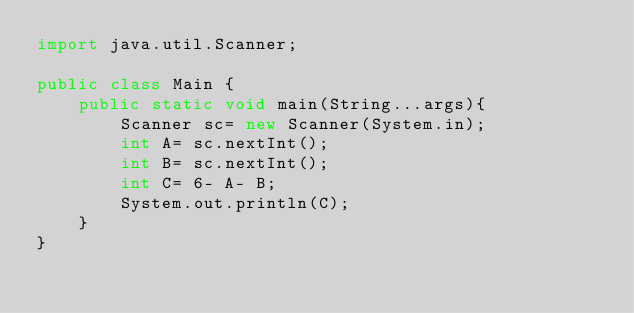Convert code to text. <code><loc_0><loc_0><loc_500><loc_500><_Java_>import java.util.Scanner;

public class Main {
    public static void main(String...args){
        Scanner sc= new Scanner(System.in);
        int A= sc.nextInt();
        int B= sc.nextInt();
        int C= 6- A- B;
        System.out.println(C);
    }
}
</code> 